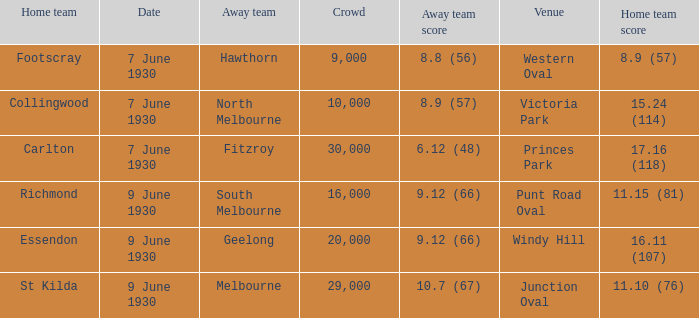Where did the away team score 8.9 (57)? Victoria Park. 